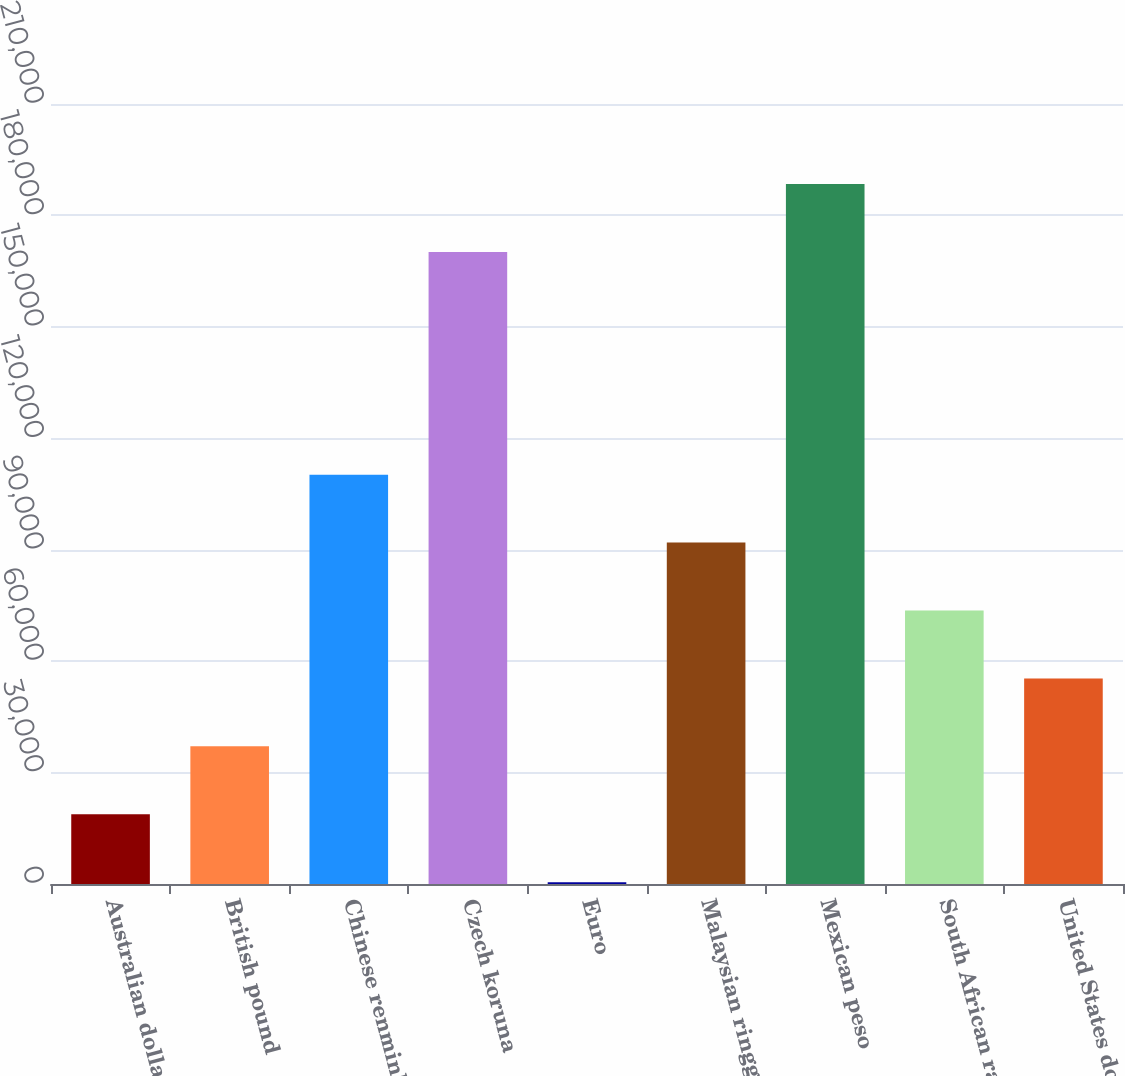Convert chart. <chart><loc_0><loc_0><loc_500><loc_500><bar_chart><fcel>Australian dollar<fcel>British pound<fcel>Chinese renminbi<fcel>Czech koruna<fcel>Euro<fcel>Malaysian ringgit<fcel>Mexican peso<fcel>South African rand<fcel>United States dollar<nl><fcel>18776.3<fcel>37060.6<fcel>110198<fcel>170145<fcel>492<fcel>91913.5<fcel>188429<fcel>73629.2<fcel>55344.9<nl></chart> 